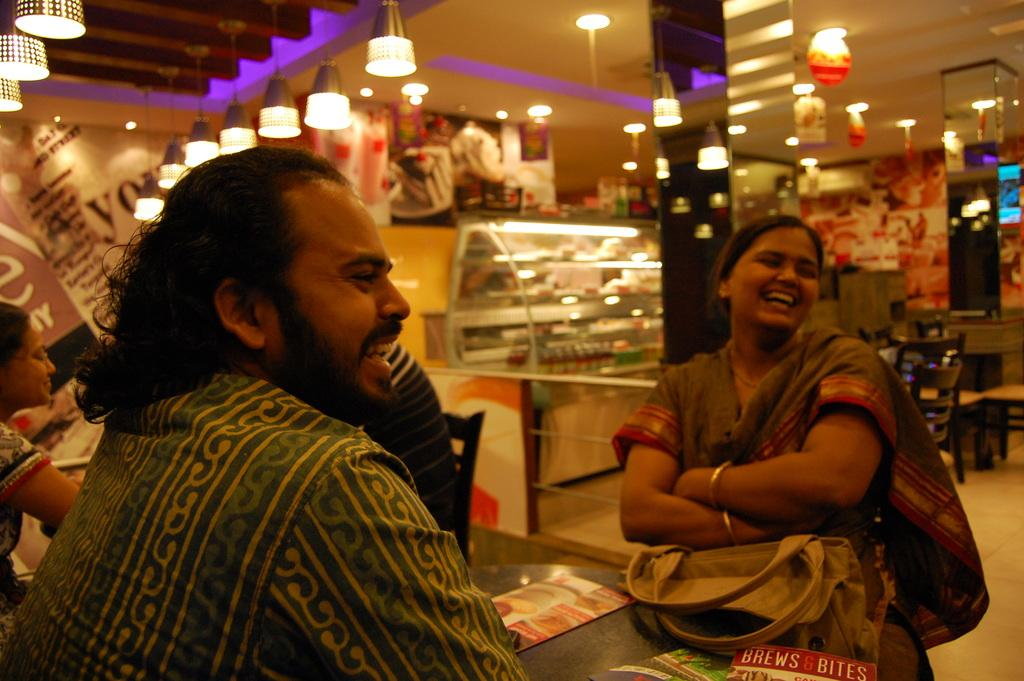How many people are in the image? There are two people in the image. Can you describe the gender of the people? One of the people is a woman, and the other person is a man. What are the people doing in the image? Both the woman and the man are sitting and laughing. What is present in the image besides the people? There is a table, lights, lanterns, and additional tables in the background of the image. What type of shoes is the secretary wearing in the image? There is no secretary present in the image, and therefore no shoes to describe. 